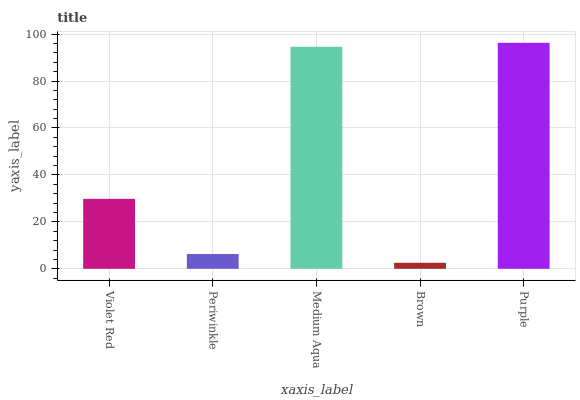Is Brown the minimum?
Answer yes or no. Yes. Is Purple the maximum?
Answer yes or no. Yes. Is Periwinkle the minimum?
Answer yes or no. No. Is Periwinkle the maximum?
Answer yes or no. No. Is Violet Red greater than Periwinkle?
Answer yes or no. Yes. Is Periwinkle less than Violet Red?
Answer yes or no. Yes. Is Periwinkle greater than Violet Red?
Answer yes or no. No. Is Violet Red less than Periwinkle?
Answer yes or no. No. Is Violet Red the high median?
Answer yes or no. Yes. Is Violet Red the low median?
Answer yes or no. Yes. Is Periwinkle the high median?
Answer yes or no. No. Is Purple the low median?
Answer yes or no. No. 